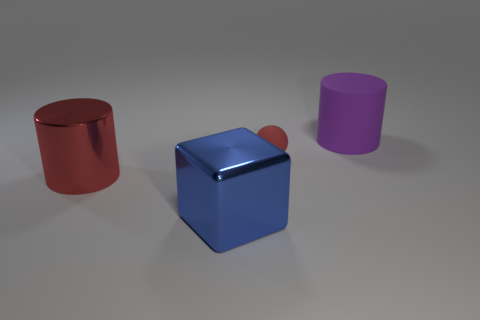Is there anything about the lighting or the surface on which the objects rest that you can tell me? The objects are situated on a flat surface with a subtle texture, possibly indicative of a synthetic or computer-generated environment. The lighting is diffuse and soft, casting faint shadows to the right of the objects, suggesting a light source to the left and slightly above the scene. This even lighting helps accentuate the objects' colors and reflective qualities without creating harsh reflections or shadows. 